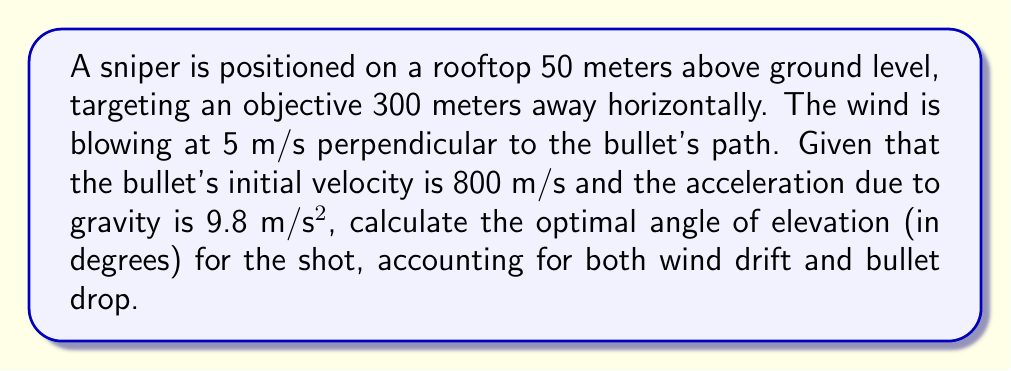Give your solution to this math problem. To solve this problem, we need to consider both the vertical and horizontal components of the bullet's trajectory:

1. Time of flight:
   The horizontal distance is 300 m, and the horizontal velocity is constant at 800 m/s.
   Time = Distance / Velocity = 300 / 800 = 0.375 seconds

2. Vertical displacement:
   Using the equation: $y = y_0 + v_0y t - \frac{1}{2}gt^2$
   Where $y_0 = 50$ m (initial height), $t = 0.375$ s, and $g = 9.8$ m/s²
   
   $0 = 50 + v_0y(0.375) - \frac{1}{2}(9.8)(0.375)^2$
   $v_0y = \frac{-50 + \frac{1}{2}(9.8)(0.375)^2}{0.375} = -131.65$ m/s

3. Wind drift:
   Wind displacement = Wind speed × Time = 5 × 0.375 = 1.875 m

4. Angle calculation:
   The vertical component of velocity is -131.65 m/s
   The horizontal component is 800 m/s
   
   Using trigonometry: $\tan \theta = \frac{|-131.65|}{800} = 0.164563$
   
   $\theta = \arctan(0.164563) = 9.34°$

5. Adjusting for wind drift:
   Wind angle adjustment = $\arctan(\frac{1.875}{300}) = 0.36°$

6. Final angle:
   Optimal angle = Elevation angle + Wind adjustment = 9.34° + 0.36° = 9.70°
Answer: 9.70° 